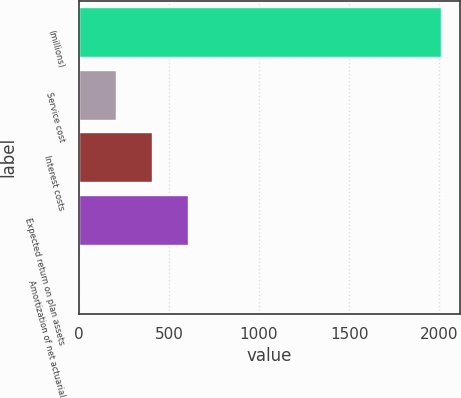<chart> <loc_0><loc_0><loc_500><loc_500><bar_chart><fcel>(millions)<fcel>Service cost<fcel>Interest costs<fcel>Expected return on plan assets<fcel>Amortization of net actuarial<nl><fcel>2012<fcel>204.35<fcel>405.2<fcel>606.05<fcel>3.5<nl></chart> 